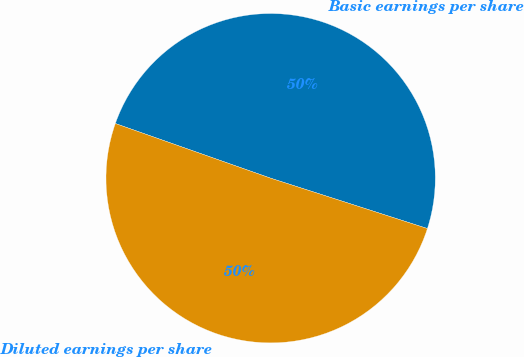Convert chart. <chart><loc_0><loc_0><loc_500><loc_500><pie_chart><fcel>Basic earnings per share<fcel>Diluted earnings per share<nl><fcel>49.56%<fcel>50.44%<nl></chart> 